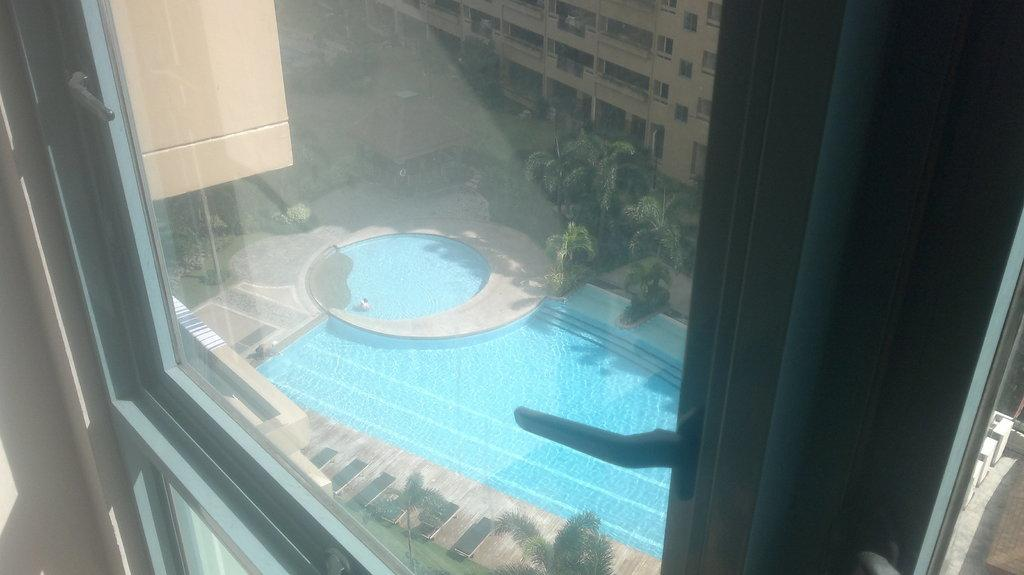What is the perspective of the image? The image is a view from a window. What can be seen outside the window? There is a swimming pool, trees, and a building visible from the window. What type of verse is being recited by the pets in the image? There are no pets present in the image, and therefore no recitation of verse can be observed. 